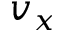<formula> <loc_0><loc_0><loc_500><loc_500>v _ { x }</formula> 